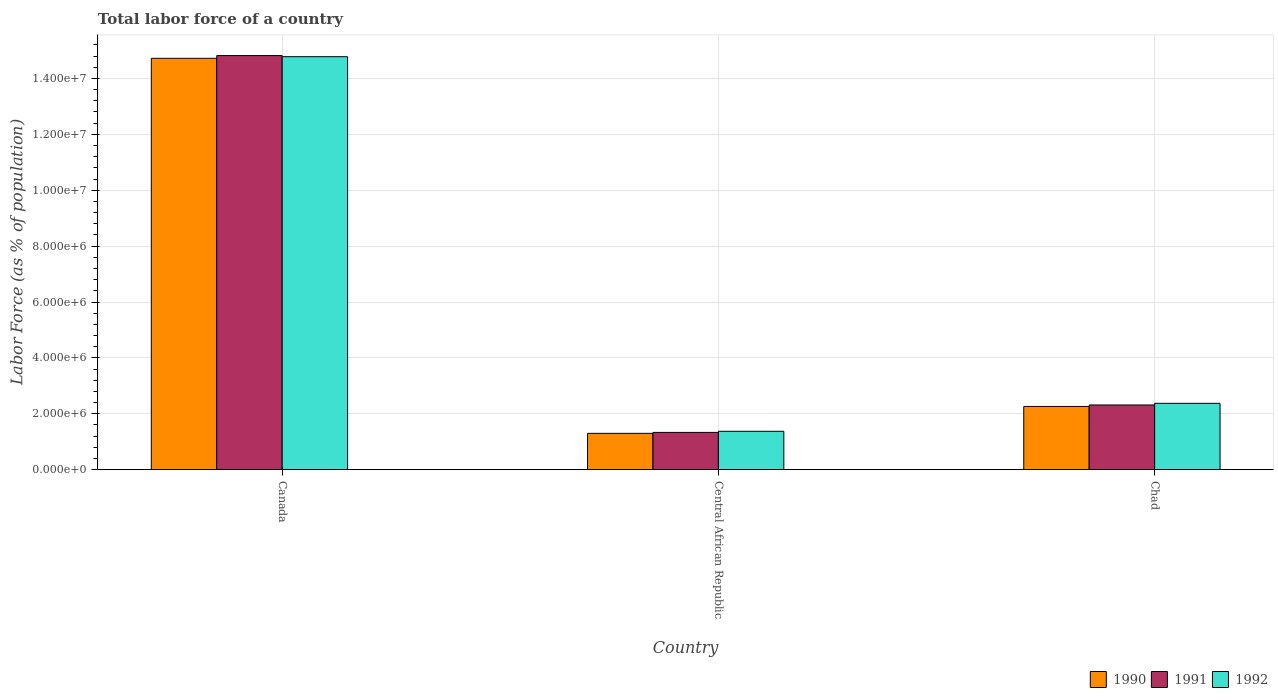How many groups of bars are there?
Keep it short and to the point. 3. Are the number of bars on each tick of the X-axis equal?
Provide a succinct answer. Yes. How many bars are there on the 3rd tick from the left?
Your answer should be compact. 3. What is the label of the 1st group of bars from the left?
Your answer should be compact. Canada. What is the percentage of labor force in 1991 in Canada?
Give a very brief answer. 1.48e+07. Across all countries, what is the maximum percentage of labor force in 1992?
Provide a short and direct response. 1.48e+07. Across all countries, what is the minimum percentage of labor force in 1990?
Your answer should be compact. 1.30e+06. In which country was the percentage of labor force in 1991 maximum?
Your answer should be compact. Canada. In which country was the percentage of labor force in 1992 minimum?
Keep it short and to the point. Central African Republic. What is the total percentage of labor force in 1990 in the graph?
Give a very brief answer. 1.83e+07. What is the difference between the percentage of labor force in 1991 in Central African Republic and that in Chad?
Your answer should be very brief. -9.81e+05. What is the difference between the percentage of labor force in 1991 in Canada and the percentage of labor force in 1990 in Central African Republic?
Make the answer very short. 1.35e+07. What is the average percentage of labor force in 1990 per country?
Offer a terse response. 6.09e+06. What is the difference between the percentage of labor force of/in 1991 and percentage of labor force of/in 1992 in Central African Republic?
Ensure brevity in your answer.  -4.00e+04. In how many countries, is the percentage of labor force in 1992 greater than 12000000 %?
Make the answer very short. 1. What is the ratio of the percentage of labor force in 1991 in Canada to that in Central African Republic?
Provide a short and direct response. 11.11. Is the percentage of labor force in 1992 in Central African Republic less than that in Chad?
Provide a succinct answer. Yes. What is the difference between the highest and the second highest percentage of labor force in 1990?
Provide a succinct answer. 1.25e+07. What is the difference between the highest and the lowest percentage of labor force in 1991?
Give a very brief answer. 1.35e+07. In how many countries, is the percentage of labor force in 1992 greater than the average percentage of labor force in 1992 taken over all countries?
Your answer should be compact. 1. What does the 2nd bar from the left in Chad represents?
Provide a short and direct response. 1991. Is it the case that in every country, the sum of the percentage of labor force in 1991 and percentage of labor force in 1990 is greater than the percentage of labor force in 1992?
Provide a succinct answer. Yes. How many bars are there?
Your answer should be very brief. 9. What is the difference between two consecutive major ticks on the Y-axis?
Keep it short and to the point. 2.00e+06. Does the graph contain grids?
Offer a terse response. Yes. How many legend labels are there?
Offer a terse response. 3. How are the legend labels stacked?
Your answer should be compact. Horizontal. What is the title of the graph?
Make the answer very short. Total labor force of a country. What is the label or title of the Y-axis?
Give a very brief answer. Labor Force (as % of population). What is the Labor Force (as % of population) of 1990 in Canada?
Make the answer very short. 1.47e+07. What is the Labor Force (as % of population) in 1991 in Canada?
Provide a short and direct response. 1.48e+07. What is the Labor Force (as % of population) in 1992 in Canada?
Make the answer very short. 1.48e+07. What is the Labor Force (as % of population) of 1990 in Central African Republic?
Provide a short and direct response. 1.30e+06. What is the Labor Force (as % of population) of 1991 in Central African Republic?
Offer a very short reply. 1.33e+06. What is the Labor Force (as % of population) of 1992 in Central African Republic?
Your answer should be compact. 1.37e+06. What is the Labor Force (as % of population) of 1990 in Chad?
Offer a terse response. 2.26e+06. What is the Labor Force (as % of population) in 1991 in Chad?
Make the answer very short. 2.32e+06. What is the Labor Force (as % of population) of 1992 in Chad?
Offer a terse response. 2.37e+06. Across all countries, what is the maximum Labor Force (as % of population) of 1990?
Provide a succinct answer. 1.47e+07. Across all countries, what is the maximum Labor Force (as % of population) of 1991?
Your response must be concise. 1.48e+07. Across all countries, what is the maximum Labor Force (as % of population) of 1992?
Your response must be concise. 1.48e+07. Across all countries, what is the minimum Labor Force (as % of population) in 1990?
Keep it short and to the point. 1.30e+06. Across all countries, what is the minimum Labor Force (as % of population) in 1991?
Offer a terse response. 1.33e+06. Across all countries, what is the minimum Labor Force (as % of population) in 1992?
Your answer should be very brief. 1.37e+06. What is the total Labor Force (as % of population) in 1990 in the graph?
Your answer should be very brief. 1.83e+07. What is the total Labor Force (as % of population) in 1991 in the graph?
Your answer should be compact. 1.85e+07. What is the total Labor Force (as % of population) of 1992 in the graph?
Make the answer very short. 1.85e+07. What is the difference between the Labor Force (as % of population) of 1990 in Canada and that in Central African Republic?
Your answer should be very brief. 1.34e+07. What is the difference between the Labor Force (as % of population) of 1991 in Canada and that in Central African Republic?
Offer a very short reply. 1.35e+07. What is the difference between the Labor Force (as % of population) of 1992 in Canada and that in Central African Republic?
Offer a very short reply. 1.34e+07. What is the difference between the Labor Force (as % of population) in 1990 in Canada and that in Chad?
Offer a very short reply. 1.25e+07. What is the difference between the Labor Force (as % of population) of 1991 in Canada and that in Chad?
Provide a succinct answer. 1.25e+07. What is the difference between the Labor Force (as % of population) of 1992 in Canada and that in Chad?
Provide a short and direct response. 1.24e+07. What is the difference between the Labor Force (as % of population) of 1990 in Central African Republic and that in Chad?
Offer a very short reply. -9.63e+05. What is the difference between the Labor Force (as % of population) of 1991 in Central African Republic and that in Chad?
Your answer should be compact. -9.81e+05. What is the difference between the Labor Force (as % of population) of 1992 in Central African Republic and that in Chad?
Your response must be concise. -1.00e+06. What is the difference between the Labor Force (as % of population) in 1990 in Canada and the Labor Force (as % of population) in 1991 in Central African Republic?
Keep it short and to the point. 1.34e+07. What is the difference between the Labor Force (as % of population) in 1990 in Canada and the Labor Force (as % of population) in 1992 in Central African Republic?
Give a very brief answer. 1.33e+07. What is the difference between the Labor Force (as % of population) in 1991 in Canada and the Labor Force (as % of population) in 1992 in Central African Republic?
Make the answer very short. 1.34e+07. What is the difference between the Labor Force (as % of population) of 1990 in Canada and the Labor Force (as % of population) of 1991 in Chad?
Provide a succinct answer. 1.24e+07. What is the difference between the Labor Force (as % of population) of 1990 in Canada and the Labor Force (as % of population) of 1992 in Chad?
Offer a terse response. 1.23e+07. What is the difference between the Labor Force (as % of population) of 1991 in Canada and the Labor Force (as % of population) of 1992 in Chad?
Make the answer very short. 1.24e+07. What is the difference between the Labor Force (as % of population) of 1990 in Central African Republic and the Labor Force (as % of population) of 1991 in Chad?
Your response must be concise. -1.02e+06. What is the difference between the Labor Force (as % of population) of 1990 in Central African Republic and the Labor Force (as % of population) of 1992 in Chad?
Give a very brief answer. -1.07e+06. What is the difference between the Labor Force (as % of population) of 1991 in Central African Republic and the Labor Force (as % of population) of 1992 in Chad?
Your response must be concise. -1.04e+06. What is the average Labor Force (as % of population) of 1990 per country?
Make the answer very short. 6.09e+06. What is the average Labor Force (as % of population) in 1991 per country?
Provide a succinct answer. 6.16e+06. What is the average Labor Force (as % of population) in 1992 per country?
Provide a succinct answer. 6.18e+06. What is the difference between the Labor Force (as % of population) of 1990 and Labor Force (as % of population) of 1991 in Canada?
Your answer should be compact. -9.72e+04. What is the difference between the Labor Force (as % of population) of 1990 and Labor Force (as % of population) of 1992 in Canada?
Ensure brevity in your answer.  -5.76e+04. What is the difference between the Labor Force (as % of population) in 1991 and Labor Force (as % of population) in 1992 in Canada?
Offer a terse response. 3.97e+04. What is the difference between the Labor Force (as % of population) in 1990 and Labor Force (as % of population) in 1991 in Central African Republic?
Your answer should be very brief. -3.38e+04. What is the difference between the Labor Force (as % of population) in 1990 and Labor Force (as % of population) in 1992 in Central African Republic?
Ensure brevity in your answer.  -7.38e+04. What is the difference between the Labor Force (as % of population) in 1991 and Labor Force (as % of population) in 1992 in Central African Republic?
Provide a succinct answer. -4.00e+04. What is the difference between the Labor Force (as % of population) in 1990 and Labor Force (as % of population) in 1991 in Chad?
Your answer should be very brief. -5.23e+04. What is the difference between the Labor Force (as % of population) in 1990 and Labor Force (as % of population) in 1992 in Chad?
Your answer should be compact. -1.11e+05. What is the difference between the Labor Force (as % of population) in 1991 and Labor Force (as % of population) in 1992 in Chad?
Ensure brevity in your answer.  -5.92e+04. What is the ratio of the Labor Force (as % of population) in 1990 in Canada to that in Central African Republic?
Ensure brevity in your answer.  11.32. What is the ratio of the Labor Force (as % of population) in 1991 in Canada to that in Central African Republic?
Ensure brevity in your answer.  11.11. What is the ratio of the Labor Force (as % of population) in 1992 in Canada to that in Central African Republic?
Provide a succinct answer. 10.75. What is the ratio of the Labor Force (as % of population) of 1990 in Canada to that in Chad?
Your answer should be compact. 6.5. What is the ratio of the Labor Force (as % of population) in 1991 in Canada to that in Chad?
Your answer should be compact. 6.4. What is the ratio of the Labor Force (as % of population) of 1992 in Canada to that in Chad?
Offer a terse response. 6.22. What is the ratio of the Labor Force (as % of population) in 1990 in Central African Republic to that in Chad?
Provide a short and direct response. 0.57. What is the ratio of the Labor Force (as % of population) of 1991 in Central African Republic to that in Chad?
Offer a terse response. 0.58. What is the ratio of the Labor Force (as % of population) of 1992 in Central African Republic to that in Chad?
Make the answer very short. 0.58. What is the difference between the highest and the second highest Labor Force (as % of population) in 1990?
Provide a short and direct response. 1.25e+07. What is the difference between the highest and the second highest Labor Force (as % of population) of 1991?
Offer a very short reply. 1.25e+07. What is the difference between the highest and the second highest Labor Force (as % of population) in 1992?
Offer a very short reply. 1.24e+07. What is the difference between the highest and the lowest Labor Force (as % of population) of 1990?
Provide a succinct answer. 1.34e+07. What is the difference between the highest and the lowest Labor Force (as % of population) of 1991?
Ensure brevity in your answer.  1.35e+07. What is the difference between the highest and the lowest Labor Force (as % of population) of 1992?
Your answer should be compact. 1.34e+07. 